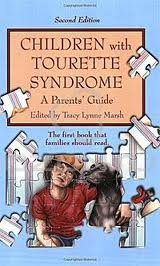Can you describe the cover art of this book? The cover features an illustration of a mother and her son, who appears to be in his youth. The son is holding a dog, possibly suggesting comfort and companionship through challenges, which is reflective of the book's themes centered around managing Tourette Syndrome. 